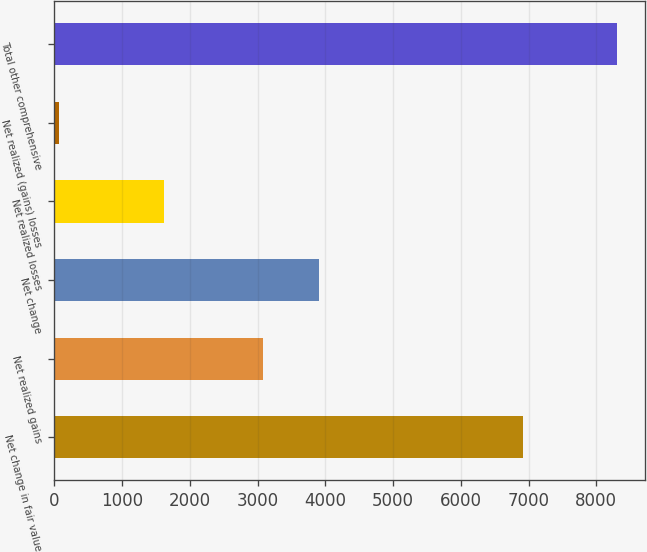Convert chart. <chart><loc_0><loc_0><loc_500><loc_500><bar_chart><fcel>Net change in fair value<fcel>Net realized gains<fcel>Net change<fcel>Net realized losses<fcel>Net realized (gains) losses<fcel>Total other comprehensive<nl><fcel>6913<fcel>3075<fcel>3898.9<fcel>1617<fcel>65<fcel>8304<nl></chart> 